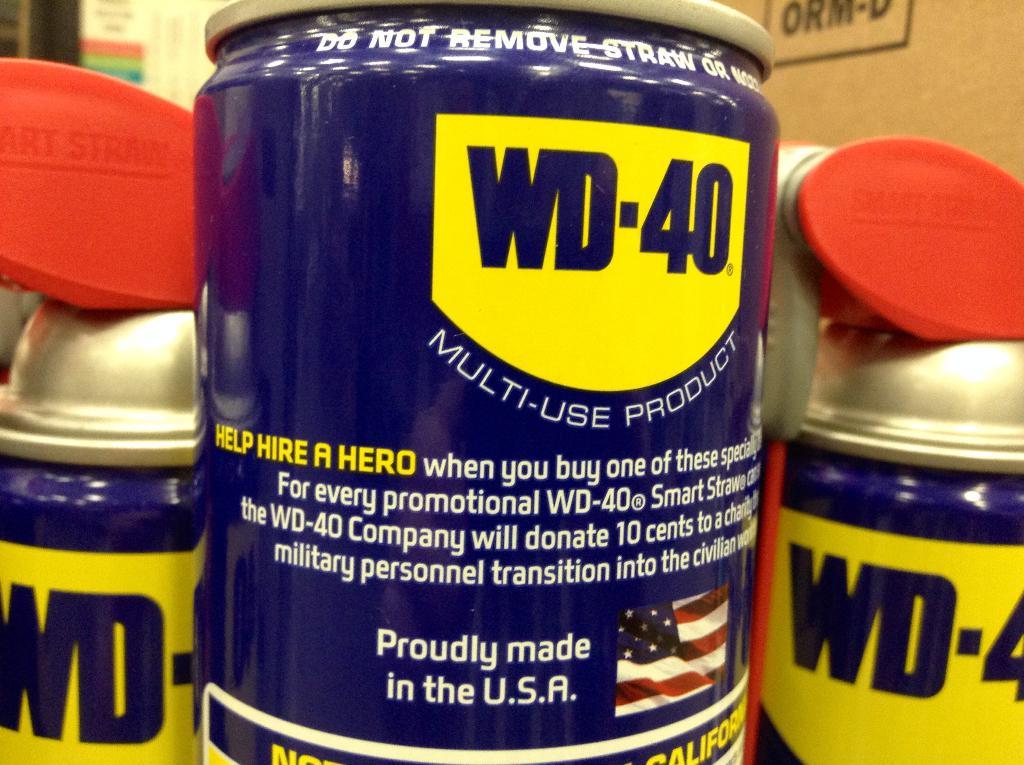What brand is this oil?
Keep it short and to the point. Wd-40. Where was this product made?
Your response must be concise. Usa. 